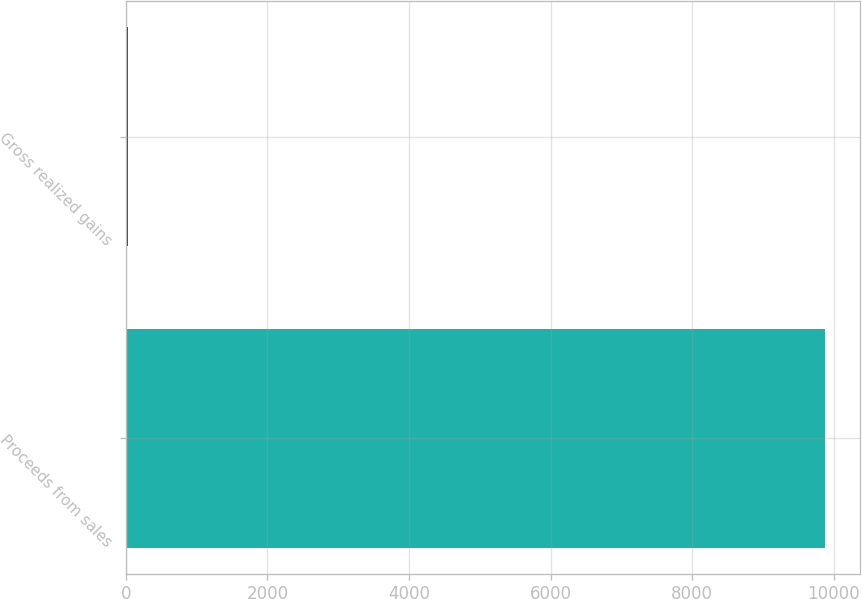Convert chart to OTSL. <chart><loc_0><loc_0><loc_500><loc_500><bar_chart><fcel>Proceeds from sales<fcel>Gross realized gains<nl><fcel>9881<fcel>36<nl></chart> 